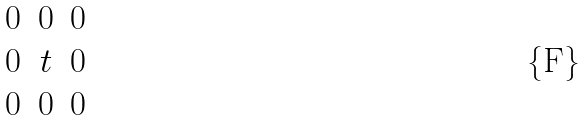<formula> <loc_0><loc_0><loc_500><loc_500>\begin{matrix} 0 & 0 & 0 \\ 0 & t & 0 \\ 0 & 0 & 0 \\ \end{matrix}</formula> 